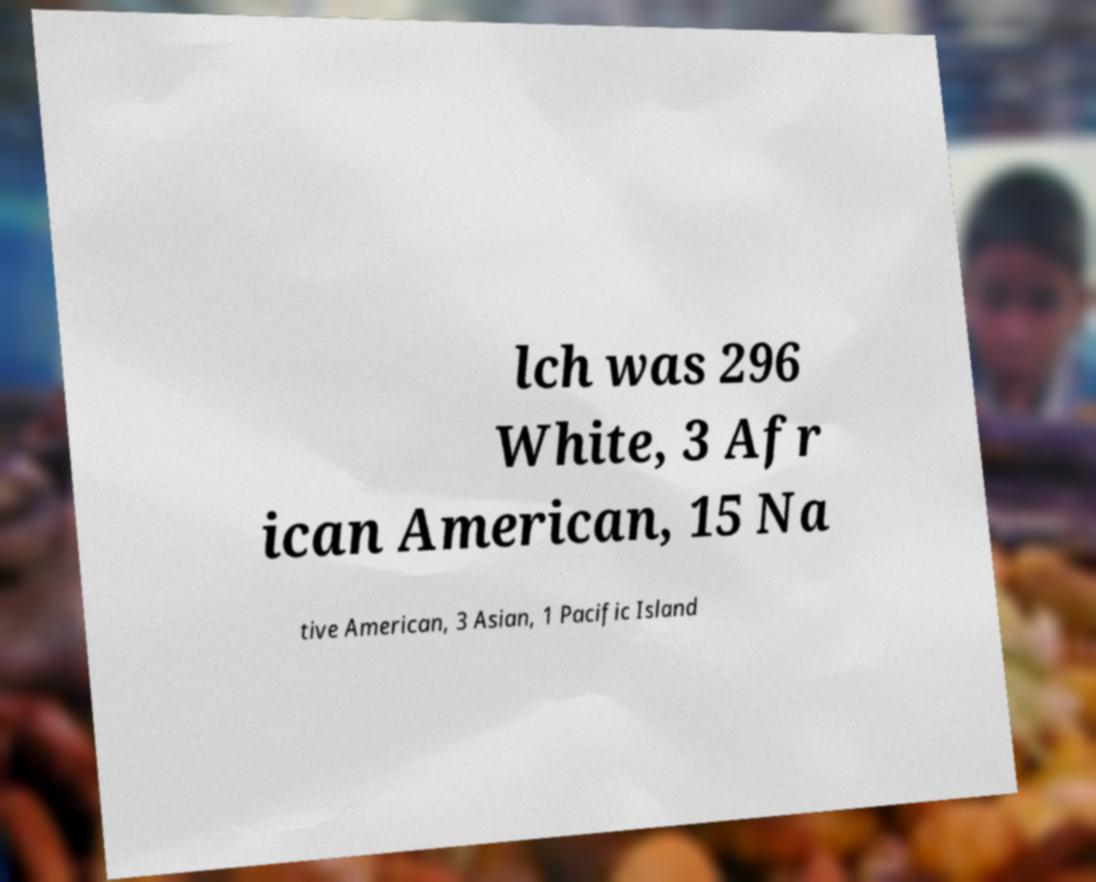Can you read and provide the text displayed in the image?This photo seems to have some interesting text. Can you extract and type it out for me? lch was 296 White, 3 Afr ican American, 15 Na tive American, 3 Asian, 1 Pacific Island 